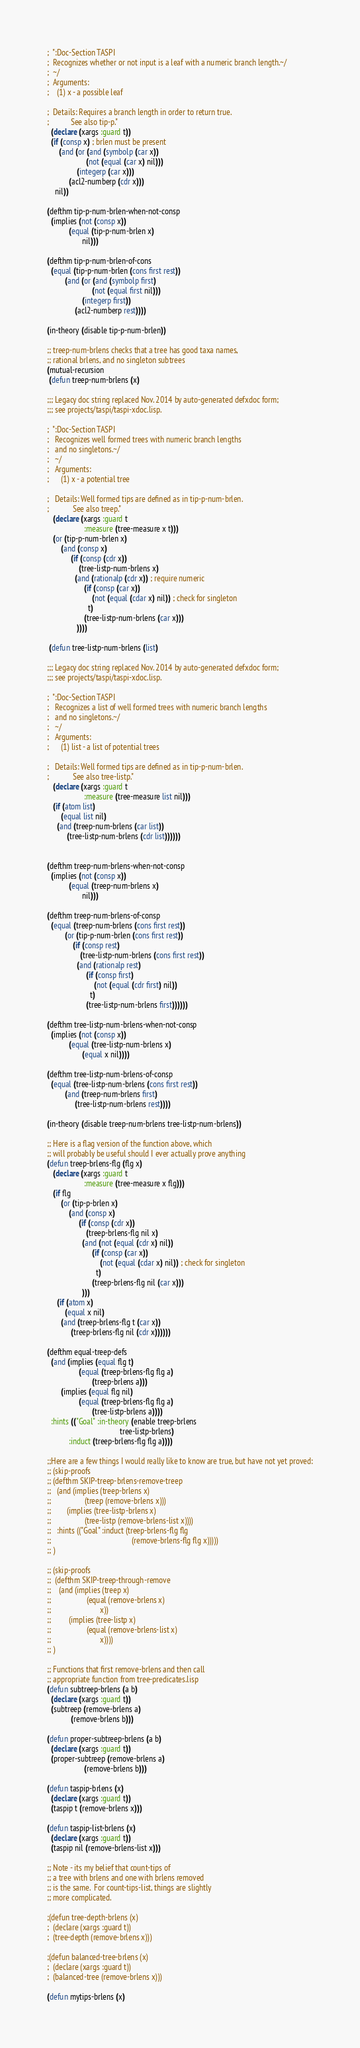Convert code to text. <code><loc_0><loc_0><loc_500><loc_500><_Lisp_>
;  ":Doc-Section TASPI
;  Recognizes whether or not input is a leaf with a numeric branch length.~/
;  ~/
;  Arguments:
;    (1) x - a possible leaf

;  Details: Requires a branch length in order to return true.
;           See also tip-p."
  (declare (xargs :guard t))
  (if (consp x) ; brlen must be present
      (and (or (and (symbolp (car x))
                    (not (equal (car x) nil)))
               (integerp (car x)))
           (acl2-numberp (cdr x)))
    nil))

(defthm tip-p-num-brlen-when-not-consp
  (implies (not (consp x))
           (equal (tip-p-num-brlen x)
                  nil)))

(defthm tip-p-num-brlen-of-cons
  (equal (tip-p-num-brlen (cons first rest))
         (and (or (and (symbolp first)
                       (not (equal first nil)))
                  (integerp first))
              (acl2-numberp rest))))

(in-theory (disable tip-p-num-brlen))

;; treep-num-brlens checks that a tree has good taxa names,
;; rational brlens, and no singleton subtrees
(mutual-recursion
 (defun treep-num-brlens (x)

;;; Legacy doc string replaced Nov. 2014 by auto-generated defxdoc form;
;;; see projects/taspi/taspi-xdoc.lisp.

;  ":Doc-Section TASPI
;   Recognizes well formed trees with numeric branch lengths
;   and no singletons.~/
;   ~/
;   Arguments:
;      (1) x - a potential tree

;   Details: Well formed tips are defined as in tip-p-num-brlen.
;            See also treep."
   (declare (xargs :guard t
                   :measure (tree-measure x t)))
   (or (tip-p-num-brlen x)
       (and (consp x)
            (if (consp (cdr x))
                (tree-listp-num-brlens x)
              (and (rationalp (cdr x)) ; require numeric
                   (if (consp (car x))
                       (not (equal (cdar x) nil)) ; check for singleton
                     t)
                   (tree-listp-num-brlens (car x)))
               ))))

 (defun tree-listp-num-brlens (list)

;;; Legacy doc string replaced Nov. 2014 by auto-generated defxdoc form;
;;; see projects/taspi/taspi-xdoc.lisp.

;  ":Doc-Section TASPI
;   Recognizes a list of well formed trees with numeric branch lengths
;   and no singletons.~/
;   ~/
;   Arguments:
;      (1) list - a list of potential trees

;   Details: Well formed tips are defined as in tip-p-num-brlen.
;            See also tree-listp."
   (declare (xargs :guard t
                   :measure (tree-measure list nil)))
   (if (atom list)
       (equal list nil)
     (and (treep-num-brlens (car list))
          (tree-listp-num-brlens (cdr list))))))


(defthm treep-num-brlens-when-not-consp
  (implies (not (consp x))
           (equal (treep-num-brlens x)
                  nil)))

(defthm treep-num-brlens-of-consp
  (equal (treep-num-brlens (cons first rest))
         (or (tip-p-num-brlen (cons first rest))
             (if (consp rest)
                 (tree-listp-num-brlens (cons first rest))
               (and (rationalp rest)
                    (if (consp first)
                        (not (equal (cdr first) nil))
                      t)
                    (tree-listp-num-brlens first))))))

(defthm tree-listp-num-brlens-when-not-consp
  (implies (not (consp x))
           (equal (tree-listp-num-brlens x)
                  (equal x nil))))

(defthm tree-listp-num-brlens-of-consp
  (equal (tree-listp-num-brlens (cons first rest))
         (and (treep-num-brlens first)
              (tree-listp-num-brlens rest))))

(in-theory (disable treep-num-brlens tree-listp-num-brlens))

;; Here is a flag version of the function above, which
;; will probably be useful should I ever actually prove anything
(defun treep-brlens-flg (flg x)
   (declare (xargs :guard t
                   :measure (tree-measure x flg)))
   (if flg
       (or (tip-p-brlen x)
           (and (consp x)
                (if (consp (cdr x))
                    (treep-brlens-flg nil x)
                  (and (not (equal (cdr x) nil))
                       (if (consp (car x))
                           (not (equal (cdar x) nil)) ; check for singleton
                         t)
                       (treep-brlens-flg nil (car x)))
                  )))
     (if (atom x)
         (equal x nil)
       (and (treep-brlens-flg t (car x))
            (treep-brlens-flg nil (cdr x))))))

(defthm equal-treep-defs
  (and (implies (equal flg t)
                (equal (treep-brlens-flg flg a)
                       (treep-brlens a)))
       (implies (equal flg nil)
                (equal (treep-brlens-flg flg a)
                       (tree-listp-brlens a))))
  :hints (("Goal" :in-theory (enable treep-brlens
                                     tree-listp-brlens)
           :induct (treep-brlens-flg flg a))))

;;Here are a few things I would really like to know are true, but have not yet proved:
;; (skip-proofs
;; (defthm SKIP-treep-brlens-remove-treep
;;   (and (implies (treep-brlens x)
;;                 (treep (remove-brlens x)))
;;        (implies (tree-listp-brlens x)
;;                 (tree-listp (remove-brlens-list x))))
;;   :hints (("Goal" :induct (treep-brlens-flg flg
;;                                         (remove-brlens-flg flg x)))))
;; )

;; (skip-proofs
;;  (defthm SKIP-treep-through-remove
;;    (and (implies (treep x)
;;                  (equal (remove-brlens x)
;;                         x))
;;         (implies (tree-listp x)
;;                  (equal (remove-brlens-list x)
;;                         x))))
;; )

;; Functions that first remove-brlens and then call
;; appropriate function from tree-predicates.lisp
(defun subtreep-brlens (a b)
  (declare (xargs :guard t))
  (subtreep (remove-brlens a)
            (remove-brlens b)))

(defun proper-subtreep-brlens (a b)
  (declare (xargs :guard t))
  (proper-subtreep (remove-brlens a)
                   (remove-brlens b)))

(defun taspip-brlens (x)
  (declare (xargs :guard t))
  (taspip t (remove-brlens x)))

(defun taspip-list-brlens (x)
  (declare (xargs :guard t))
  (taspip nil (remove-brlens-list x)))

;; Note - its my belief that count-tips of
;; a tree with brlens and one with brlens removed
;; is the same.  For count-tips-list, things are slightly
;; more complicated.

;(defun tree-depth-brlens (x)
;  (declare (xargs :guard t))
;  (tree-depth (remove-brlens x)))

;(defun balanced-tree-brlens (x)
;  (declare (xargs :guard t))
;  (balanced-tree (remove-brlens x)))

(defun mytips-brlens (x)
</code> 